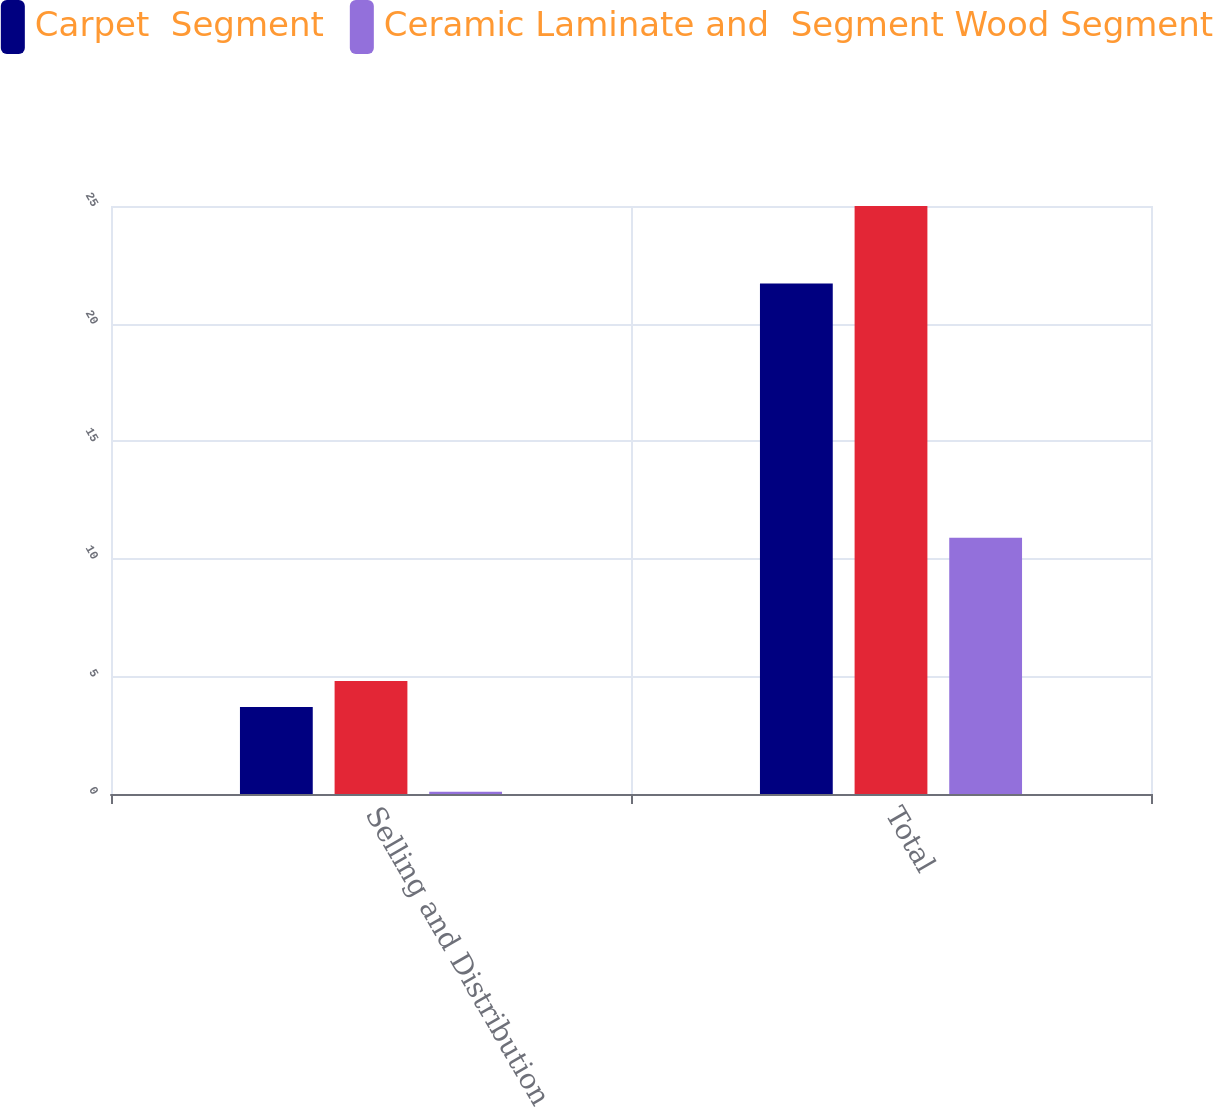Convert chart. <chart><loc_0><loc_0><loc_500><loc_500><stacked_bar_chart><ecel><fcel>Selling and Distribution<fcel>Total<nl><fcel>Carpet  Segment<fcel>3.7<fcel>21.7<nl><fcel>nan<fcel>4.8<fcel>25<nl><fcel>Ceramic Laminate and  Segment Wood Segment<fcel>0.1<fcel>10.9<nl></chart> 